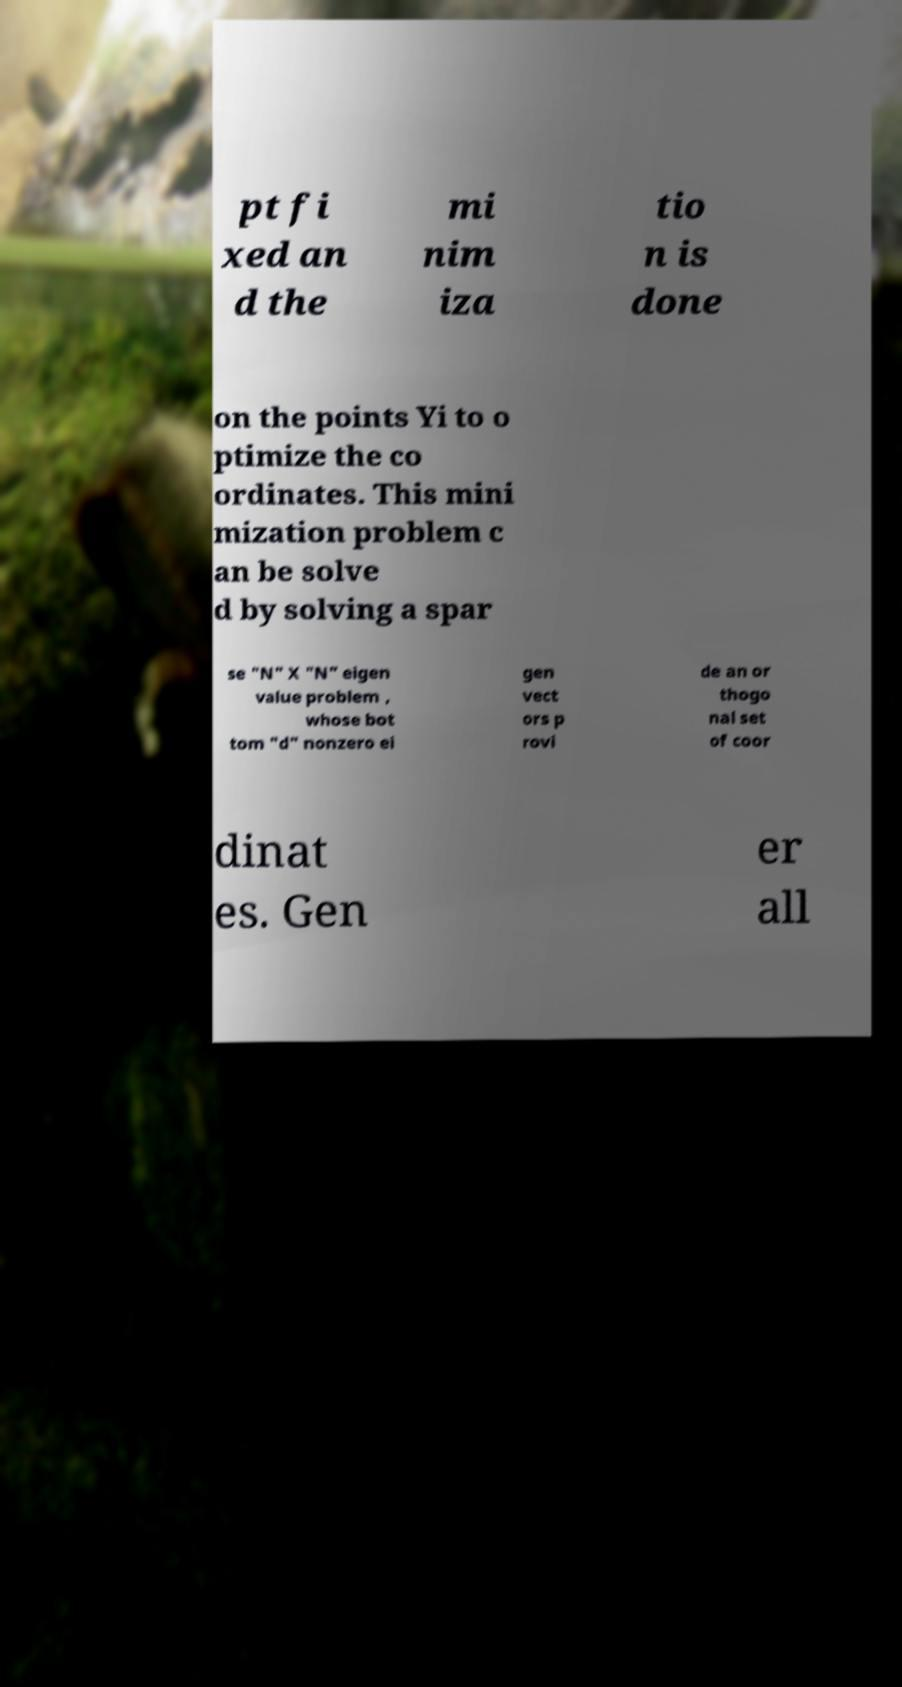Can you read and provide the text displayed in the image?This photo seems to have some interesting text. Can you extract and type it out for me? pt fi xed an d the mi nim iza tio n is done on the points Yi to o ptimize the co ordinates. This mini mization problem c an be solve d by solving a spar se "N" X "N" eigen value problem , whose bot tom "d" nonzero ei gen vect ors p rovi de an or thogo nal set of coor dinat es. Gen er all 